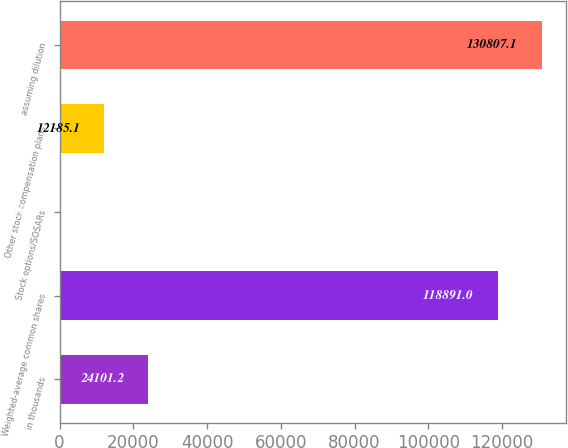Convert chart to OTSL. <chart><loc_0><loc_0><loc_500><loc_500><bar_chart><fcel>in thousands<fcel>Weighted-average common shares<fcel>Stock options/SOSARs<fcel>Other stock compensation plans<fcel>assuming dilution<nl><fcel>24101.2<fcel>118891<fcel>269<fcel>12185.1<fcel>130807<nl></chart> 